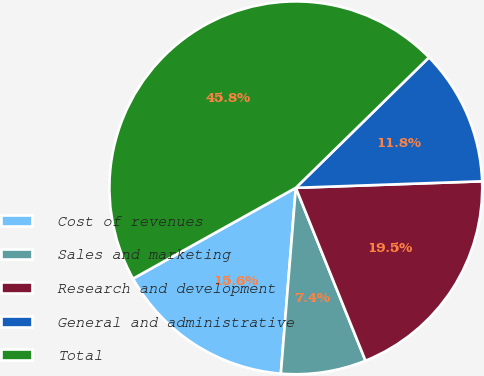<chart> <loc_0><loc_0><loc_500><loc_500><pie_chart><fcel>Cost of revenues<fcel>Sales and marketing<fcel>Research and development<fcel>General and administrative<fcel>Total<nl><fcel>15.62%<fcel>7.38%<fcel>19.46%<fcel>11.78%<fcel>45.77%<nl></chart> 